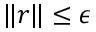<formula> <loc_0><loc_0><loc_500><loc_500>\| r \| \leq \epsilon</formula> 